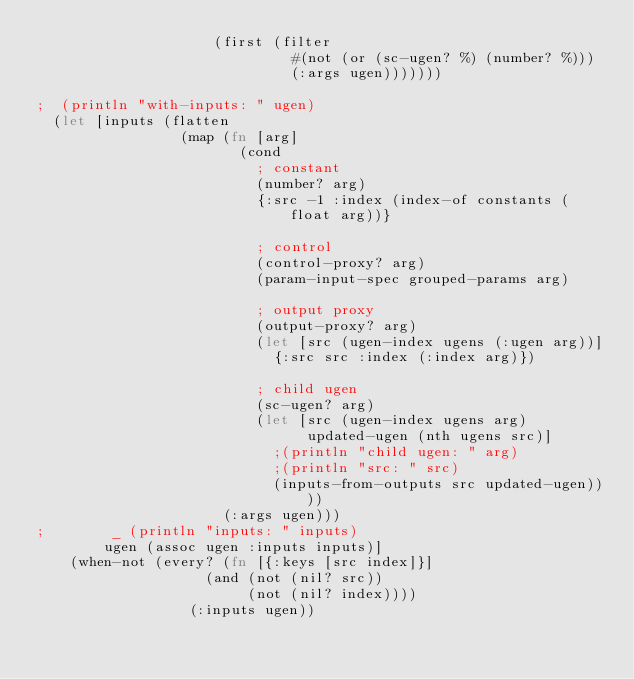Convert code to text. <code><loc_0><loc_0><loc_500><loc_500><_Clojure_>                     (first (filter
                              #(not (or (sc-ugen? %) (number? %)))
                              (:args ugen)))))))

;  (println "with-inputs: " ugen)
  (let [inputs (flatten
                 (map (fn [arg]
                        (cond
                          ; constant
                          (number? arg)
                          {:src -1 :index (index-of constants (float arg))}

                          ; control
                          (control-proxy? arg)
                          (param-input-spec grouped-params arg)

                          ; output proxy
                          (output-proxy? arg)
                          (let [src (ugen-index ugens (:ugen arg))]
                            {:src src :index (:index arg)})

                          ; child ugen
                          (sc-ugen? arg)
                          (let [src (ugen-index ugens arg)
                                updated-ugen (nth ugens src)]
                            ;(println "child ugen: " arg)
                            ;(println "src: " src)
                            (inputs-from-outputs src updated-ugen))))
                      (:args ugen)))
;        _ (println "inputs: " inputs)
        ugen (assoc ugen :inputs inputs)]
    (when-not (every? (fn [{:keys [src index]}]
                    (and (not (nil? src))
                         (not (nil? index))))
                  (:inputs ugen))</code> 